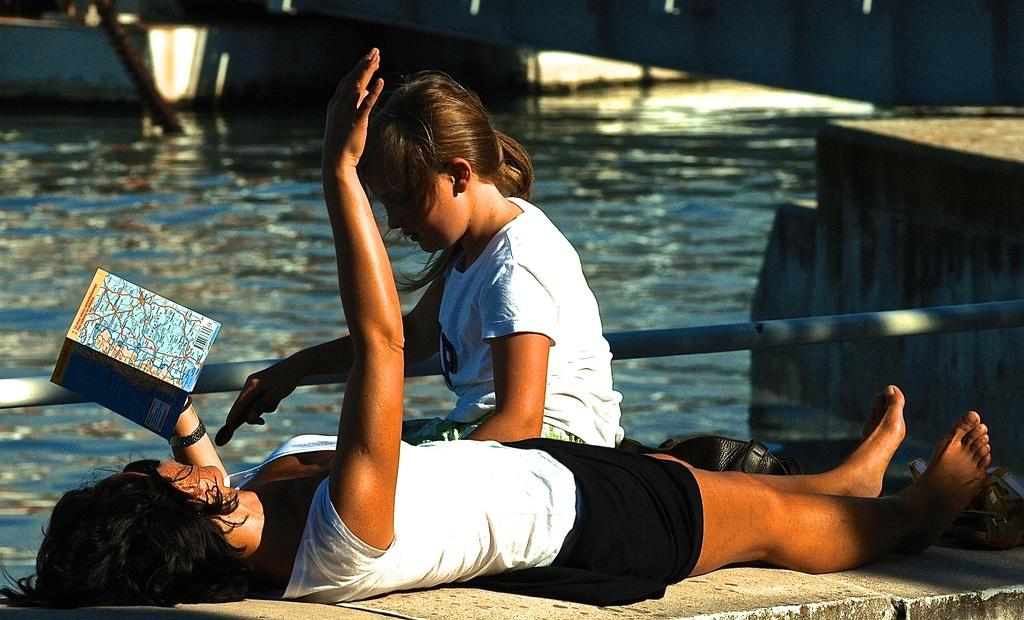Where is the woman located in the image? The woman is laying on a wall in the bottom left side of the image. What is the woman holding in the image? The woman is holding a book. What is the girl doing in the image? The girl is sitting in the middle of the image. What is behind the girl in the image? There is a fencing behind the girl. What can be seen beyond the fencing in the image? There is water visible behind the girl and the fencing. What type of linen is being used to cover the water in the image? There is no linen present in the image; the water is visible without any covering. 